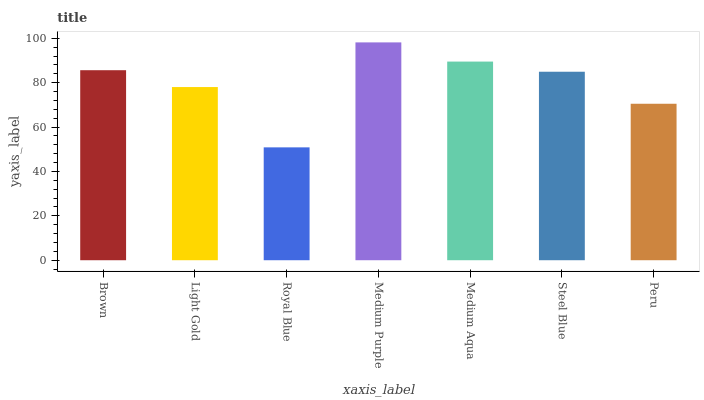Is Royal Blue the minimum?
Answer yes or no. Yes. Is Medium Purple the maximum?
Answer yes or no. Yes. Is Light Gold the minimum?
Answer yes or no. No. Is Light Gold the maximum?
Answer yes or no. No. Is Brown greater than Light Gold?
Answer yes or no. Yes. Is Light Gold less than Brown?
Answer yes or no. Yes. Is Light Gold greater than Brown?
Answer yes or no. No. Is Brown less than Light Gold?
Answer yes or no. No. Is Steel Blue the high median?
Answer yes or no. Yes. Is Steel Blue the low median?
Answer yes or no. Yes. Is Royal Blue the high median?
Answer yes or no. No. Is Light Gold the low median?
Answer yes or no. No. 